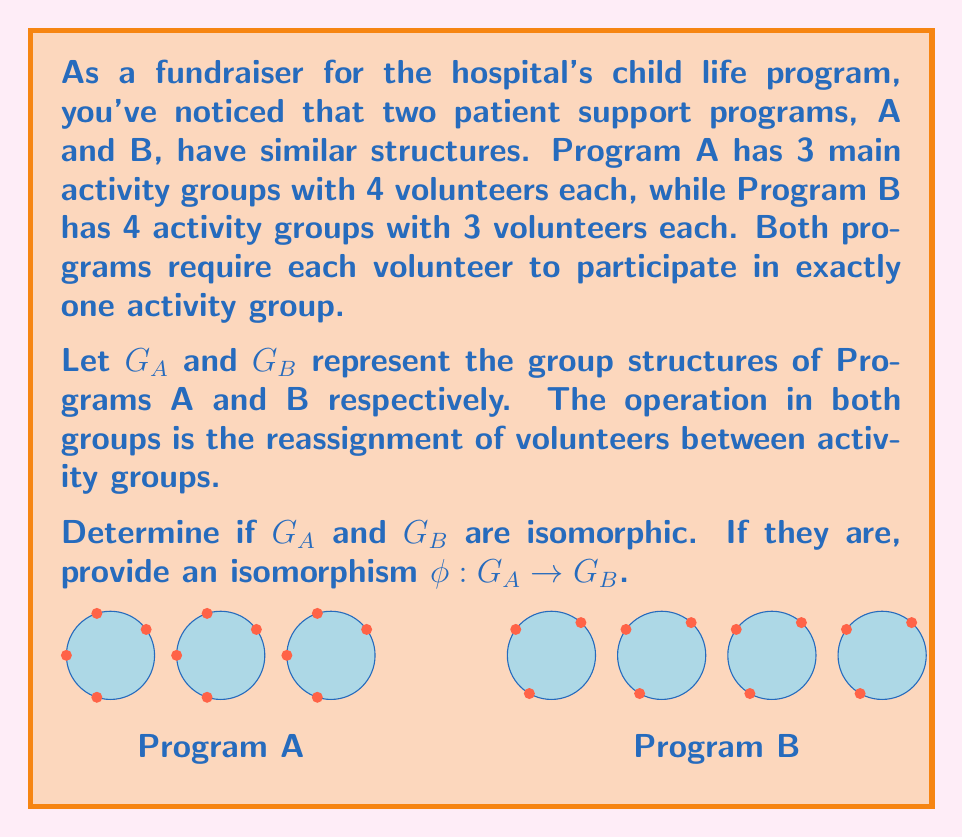Help me with this question. To determine if $G_A$ and $G_B$ are isomorphic, we need to check if they have the same group structure. Let's approach this step-by-step:

1) First, let's calculate the order of each group:
   $|G_A| = 3! \cdot (4!)^3 = 6 \cdot 24^3 = 82,944$
   $|G_B| = 4! \cdot (3!)^4 = 24 \cdot 6^4 = 5,184$

2) Since $|G_A| \neq |G_B|$, the groups cannot be isomorphic. Isomorphic groups must have the same order.

3) To understand why the orders are different:
   - In $G_A$, we can permute the 3 activity groups (3!) and within each group, we can permute the 4 volunteers (4!)^3.
   - In $G_B$, we can permute the 4 activity groups (4!) and within each group, we can permute the 3 volunteers (3!)^4.

4) The difference in structure becomes clear when we consider the cycle structure of elements in each group:
   - $G_A$ can have cycles of length up to 12 (when all 12 volunteers are in a single cycle)
   - $G_B$ can have cycles of length up to 12 as well, but the distribution of cycle types will be different

5) Since the groups are not isomorphic, we cannot provide an isomorphism $\phi: G_A \to G_B$.

This example illustrates that even when two structures seem similar at first glance (both have 12 volunteers in total), their algebraic properties can be fundamentally different.
Answer: $G_A$ and $G_B$ are not isomorphic. 